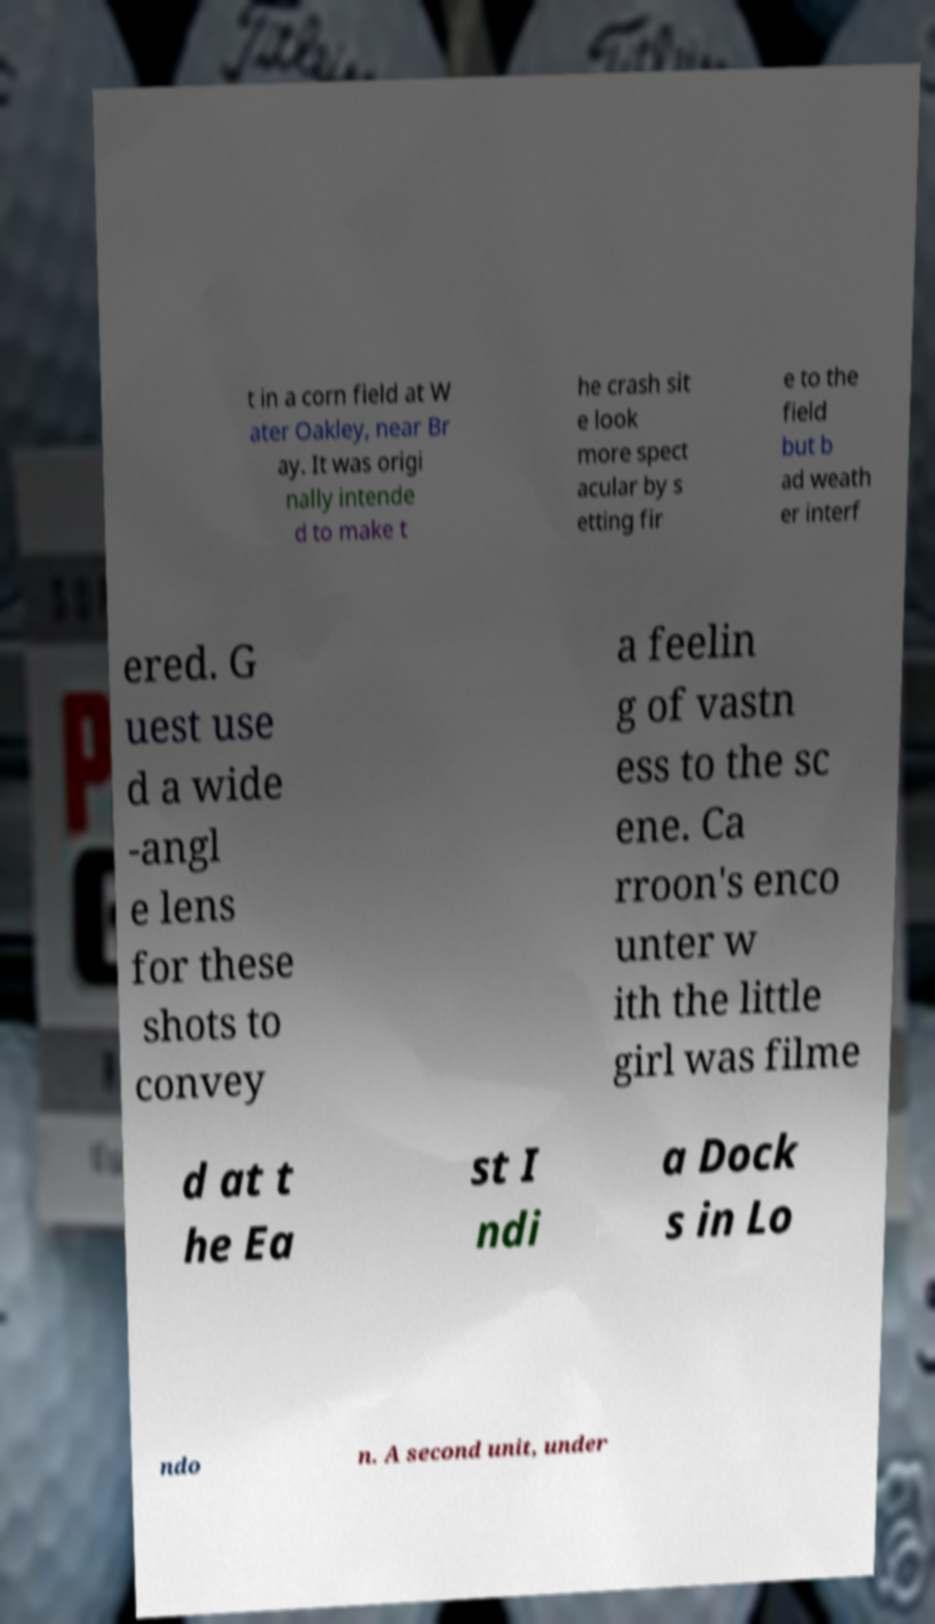There's text embedded in this image that I need extracted. Can you transcribe it verbatim? t in a corn field at W ater Oakley, near Br ay. It was origi nally intende d to make t he crash sit e look more spect acular by s etting fir e to the field but b ad weath er interf ered. G uest use d a wide -angl e lens for these shots to convey a feelin g of vastn ess to the sc ene. Ca rroon's enco unter w ith the little girl was filme d at t he Ea st I ndi a Dock s in Lo ndo n. A second unit, under 